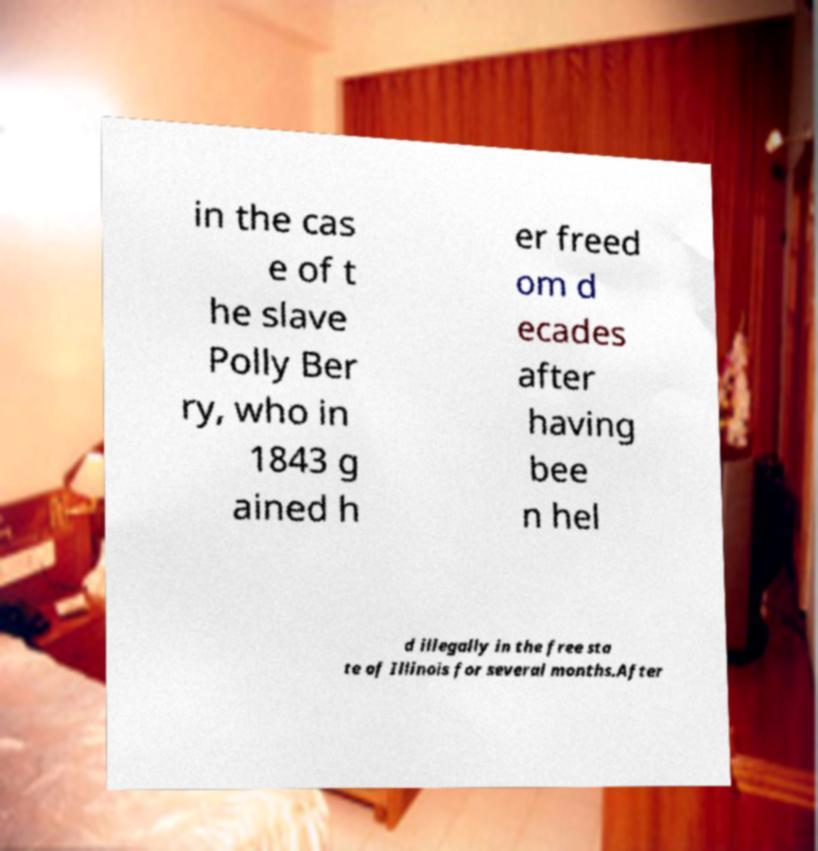Could you extract and type out the text from this image? in the cas e of t he slave Polly Ber ry, who in 1843 g ained h er freed om d ecades after having bee n hel d illegally in the free sta te of Illinois for several months.After 